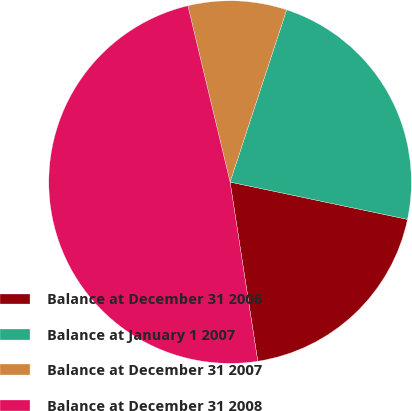<chart> <loc_0><loc_0><loc_500><loc_500><pie_chart><fcel>Balance at December 31 2006<fcel>Balance at January 1 2007<fcel>Balance at December 31 2007<fcel>Balance at December 31 2008<nl><fcel>19.26%<fcel>23.25%<fcel>8.79%<fcel>48.7%<nl></chart> 